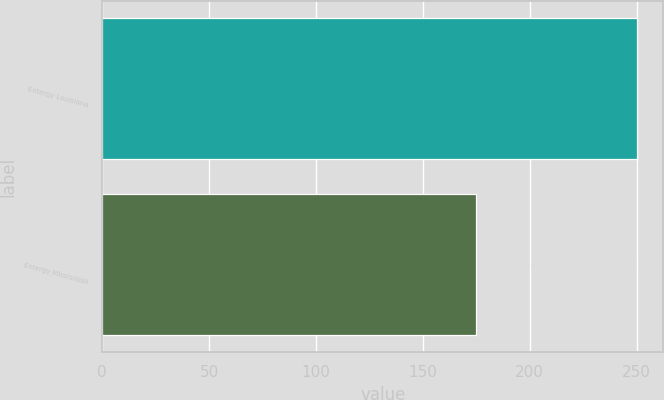<chart> <loc_0><loc_0><loc_500><loc_500><bar_chart><fcel>Entergy Louisiana<fcel>Entergy Mississippi<nl><fcel>250<fcel>175<nl></chart> 